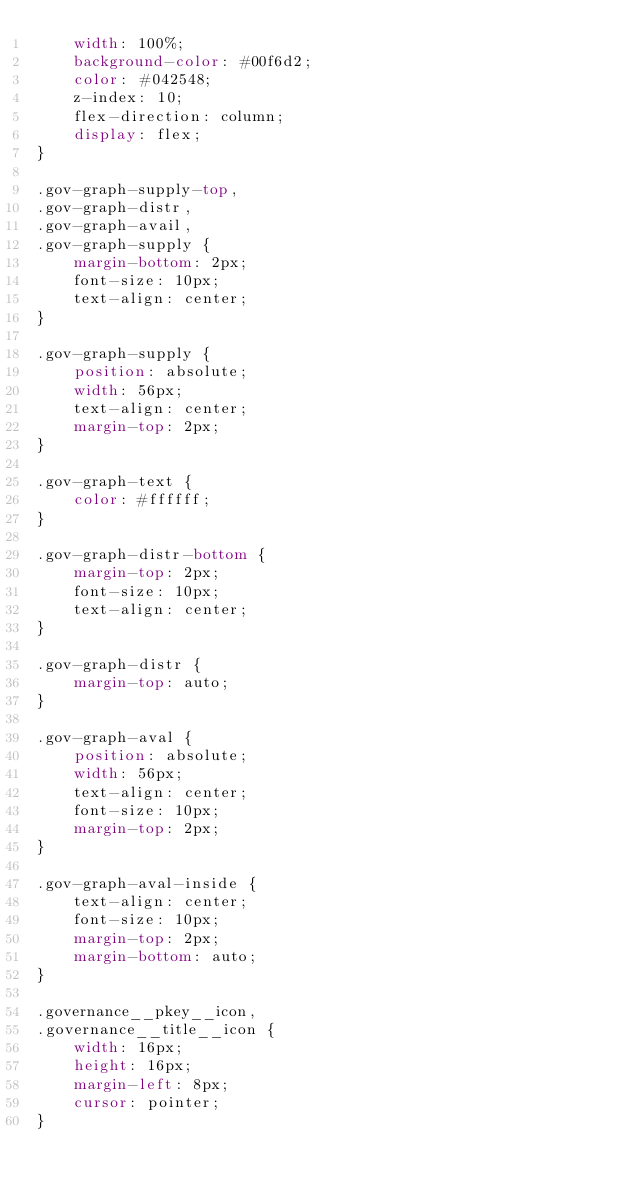Convert code to text. <code><loc_0><loc_0><loc_500><loc_500><_CSS_>    width: 100%;
    background-color: #00f6d2;
    color: #042548;
    z-index: 10;
    flex-direction: column;
    display: flex;
}

.gov-graph-supply-top,
.gov-graph-distr,
.gov-graph-avail,
.gov-graph-supply {
    margin-bottom: 2px;
    font-size: 10px;
    text-align: center;
}

.gov-graph-supply {
    position: absolute;
    width: 56px;
    text-align: center;
    margin-top: 2px;
}

.gov-graph-text {
    color: #ffffff;
}

.gov-graph-distr-bottom {
    margin-top: 2px;
    font-size: 10px;
    text-align: center;
}

.gov-graph-distr {
    margin-top: auto;
}

.gov-graph-aval {
    position: absolute;
    width: 56px;
    text-align: center;
    font-size: 10px;
    margin-top: 2px;
}

.gov-graph-aval-inside {
    text-align: center;
    font-size: 10px;
    margin-top: 2px;
    margin-bottom: auto;
}

.governance__pkey__icon,
.governance__title__icon {
    width: 16px;
    height: 16px;
    margin-left: 8px;
    cursor: pointer;
}</code> 